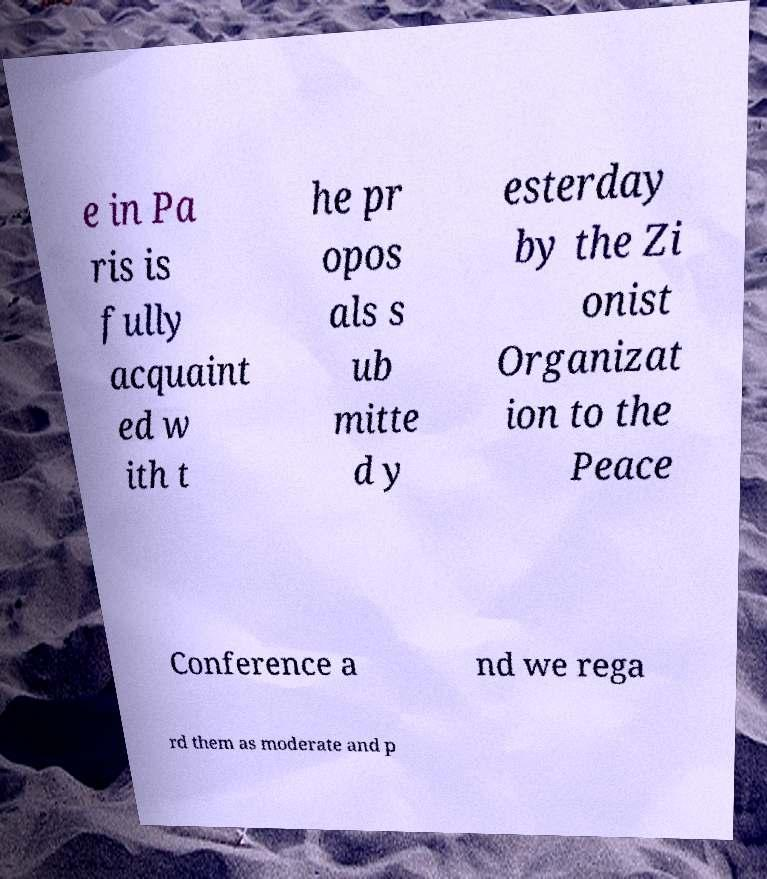There's text embedded in this image that I need extracted. Can you transcribe it verbatim? e in Pa ris is fully acquaint ed w ith t he pr opos als s ub mitte d y esterday by the Zi onist Organizat ion to the Peace Conference a nd we rega rd them as moderate and p 